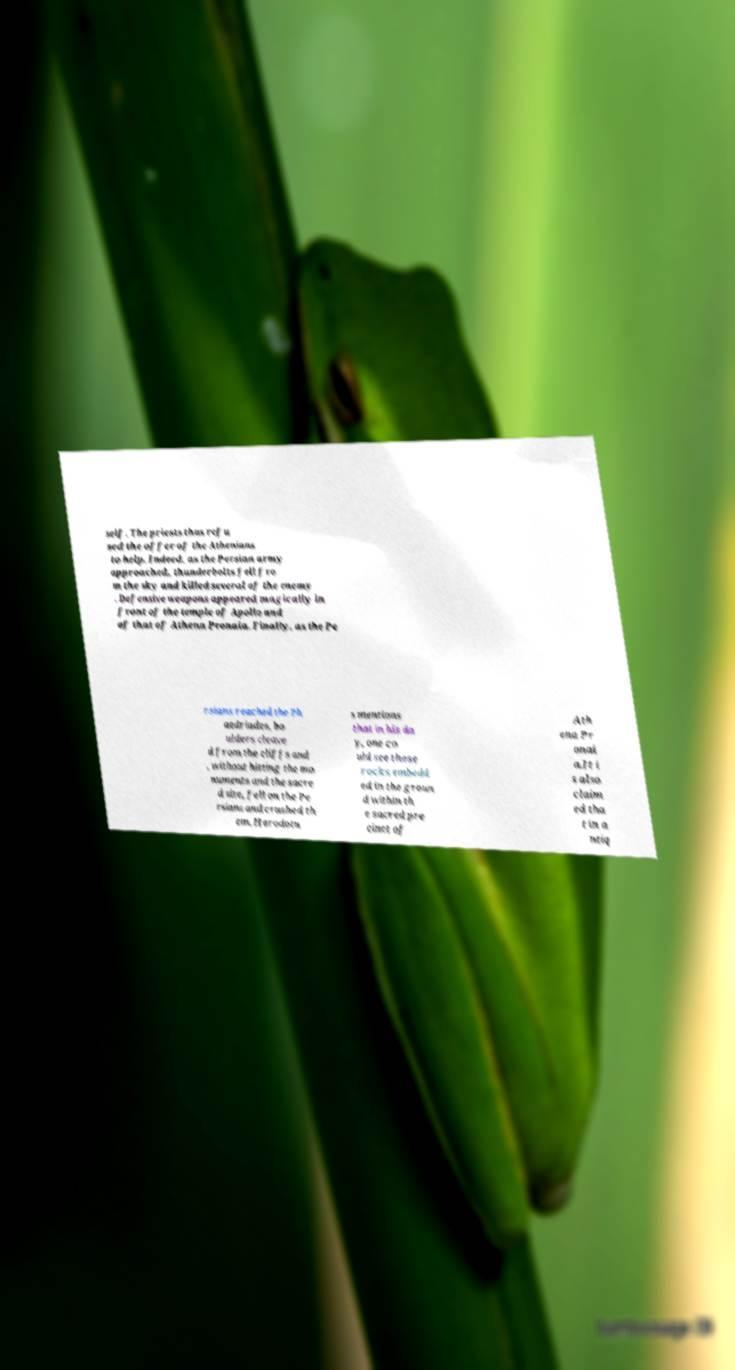Can you read and provide the text displayed in the image?This photo seems to have some interesting text. Can you extract and type it out for me? self. The priests thus refu sed the offer of the Athenians to help. Indeed, as the Persian army approached, thunderbolts fell fro m the sky and killed several of the enemy . Defensive weapons appeared magically in front of the temple of Apollo and of that of Athena Pronaia. Finally, as the Pe rsians reached the Ph aedriades, bo ulders cleave d from the cliffs and , without hitting the mo numents and the sacre d site, fell on the Pe rsians and crushed th em. Herodotu s mentions that in his da y, one co uld see these rocks embedd ed in the groun d within th e sacred pre cinct of Ath ena Pr onai a.It i s also claim ed tha t in a ntiq 